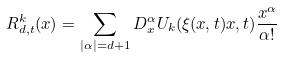<formula> <loc_0><loc_0><loc_500><loc_500>R ^ { k } _ { d , t } ( x ) & = \sum _ { | \alpha | = d + 1 } D ^ { \alpha } _ { x } U _ { k } ( \xi ( x , t ) x , t ) \frac { x ^ { \alpha } } { \alpha ! }</formula> 